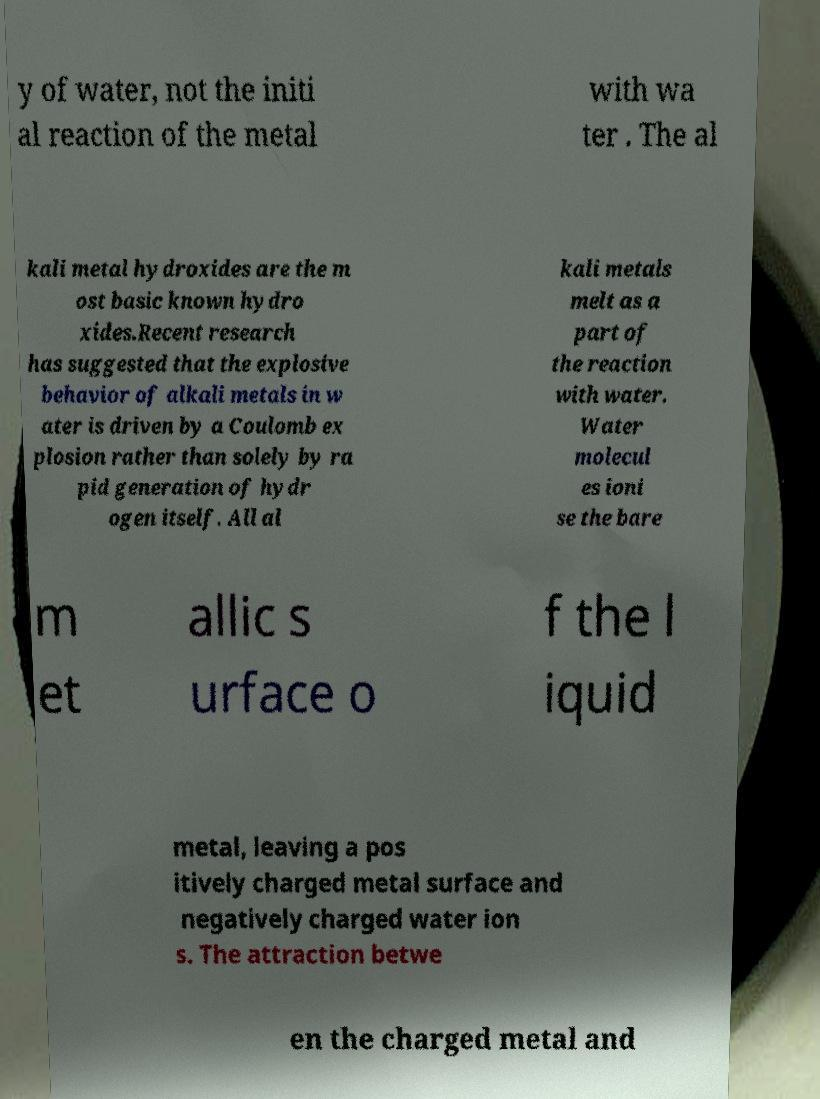Please read and relay the text visible in this image. What does it say? y of water, not the initi al reaction of the metal with wa ter . The al kali metal hydroxides are the m ost basic known hydro xides.Recent research has suggested that the explosive behavior of alkali metals in w ater is driven by a Coulomb ex plosion rather than solely by ra pid generation of hydr ogen itself. All al kali metals melt as a part of the reaction with water. Water molecul es ioni se the bare m et allic s urface o f the l iquid metal, leaving a pos itively charged metal surface and negatively charged water ion s. The attraction betwe en the charged metal and 